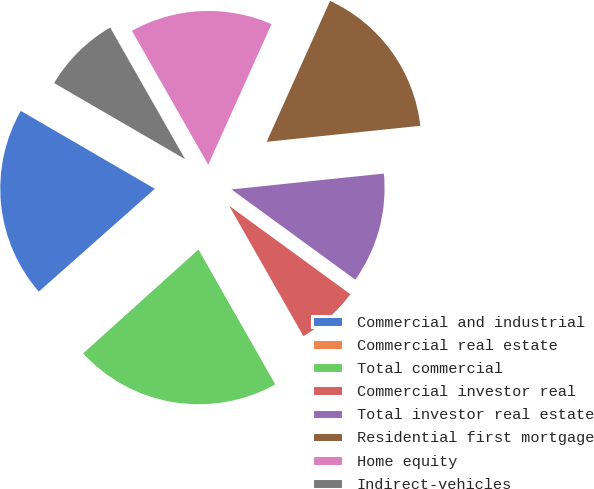Convert chart to OTSL. <chart><loc_0><loc_0><loc_500><loc_500><pie_chart><fcel>Commercial and industrial<fcel>Commercial real estate<fcel>Total commercial<fcel>Commercial investor real<fcel>Total investor real estate<fcel>Residential first mortgage<fcel>Home equity<fcel>Indirect-vehicles<nl><fcel>19.92%<fcel>0.13%<fcel>21.57%<fcel>6.73%<fcel>11.68%<fcel>16.62%<fcel>14.97%<fcel>8.38%<nl></chart> 